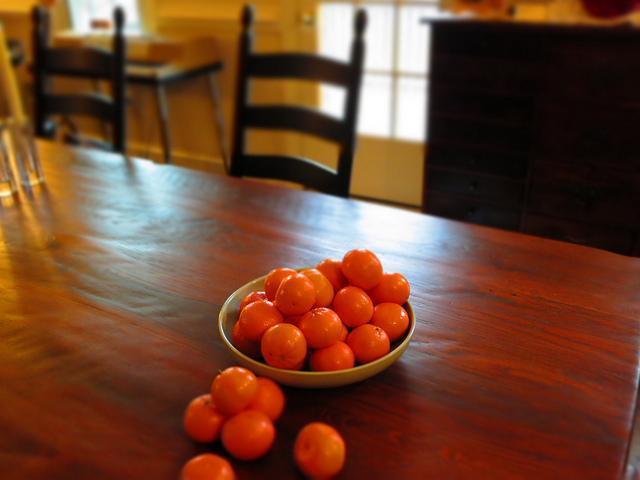How many oranges that are not in the bowl?
Give a very brief answer. 6. How many chairs are there?
Give a very brief answer. 2. How many oranges are visible?
Give a very brief answer. 3. How many people are working?
Give a very brief answer. 0. 